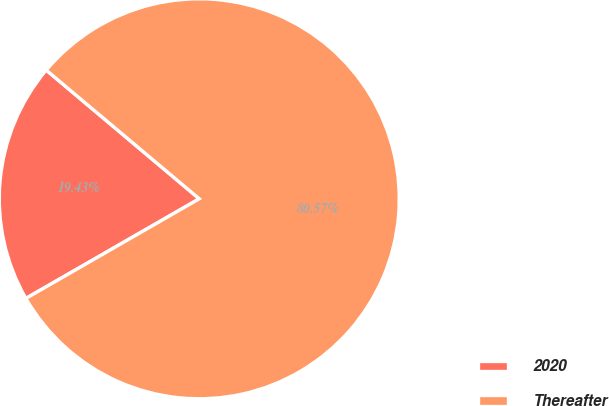Convert chart. <chart><loc_0><loc_0><loc_500><loc_500><pie_chart><fcel>2020<fcel>Thereafter<nl><fcel>19.43%<fcel>80.57%<nl></chart> 